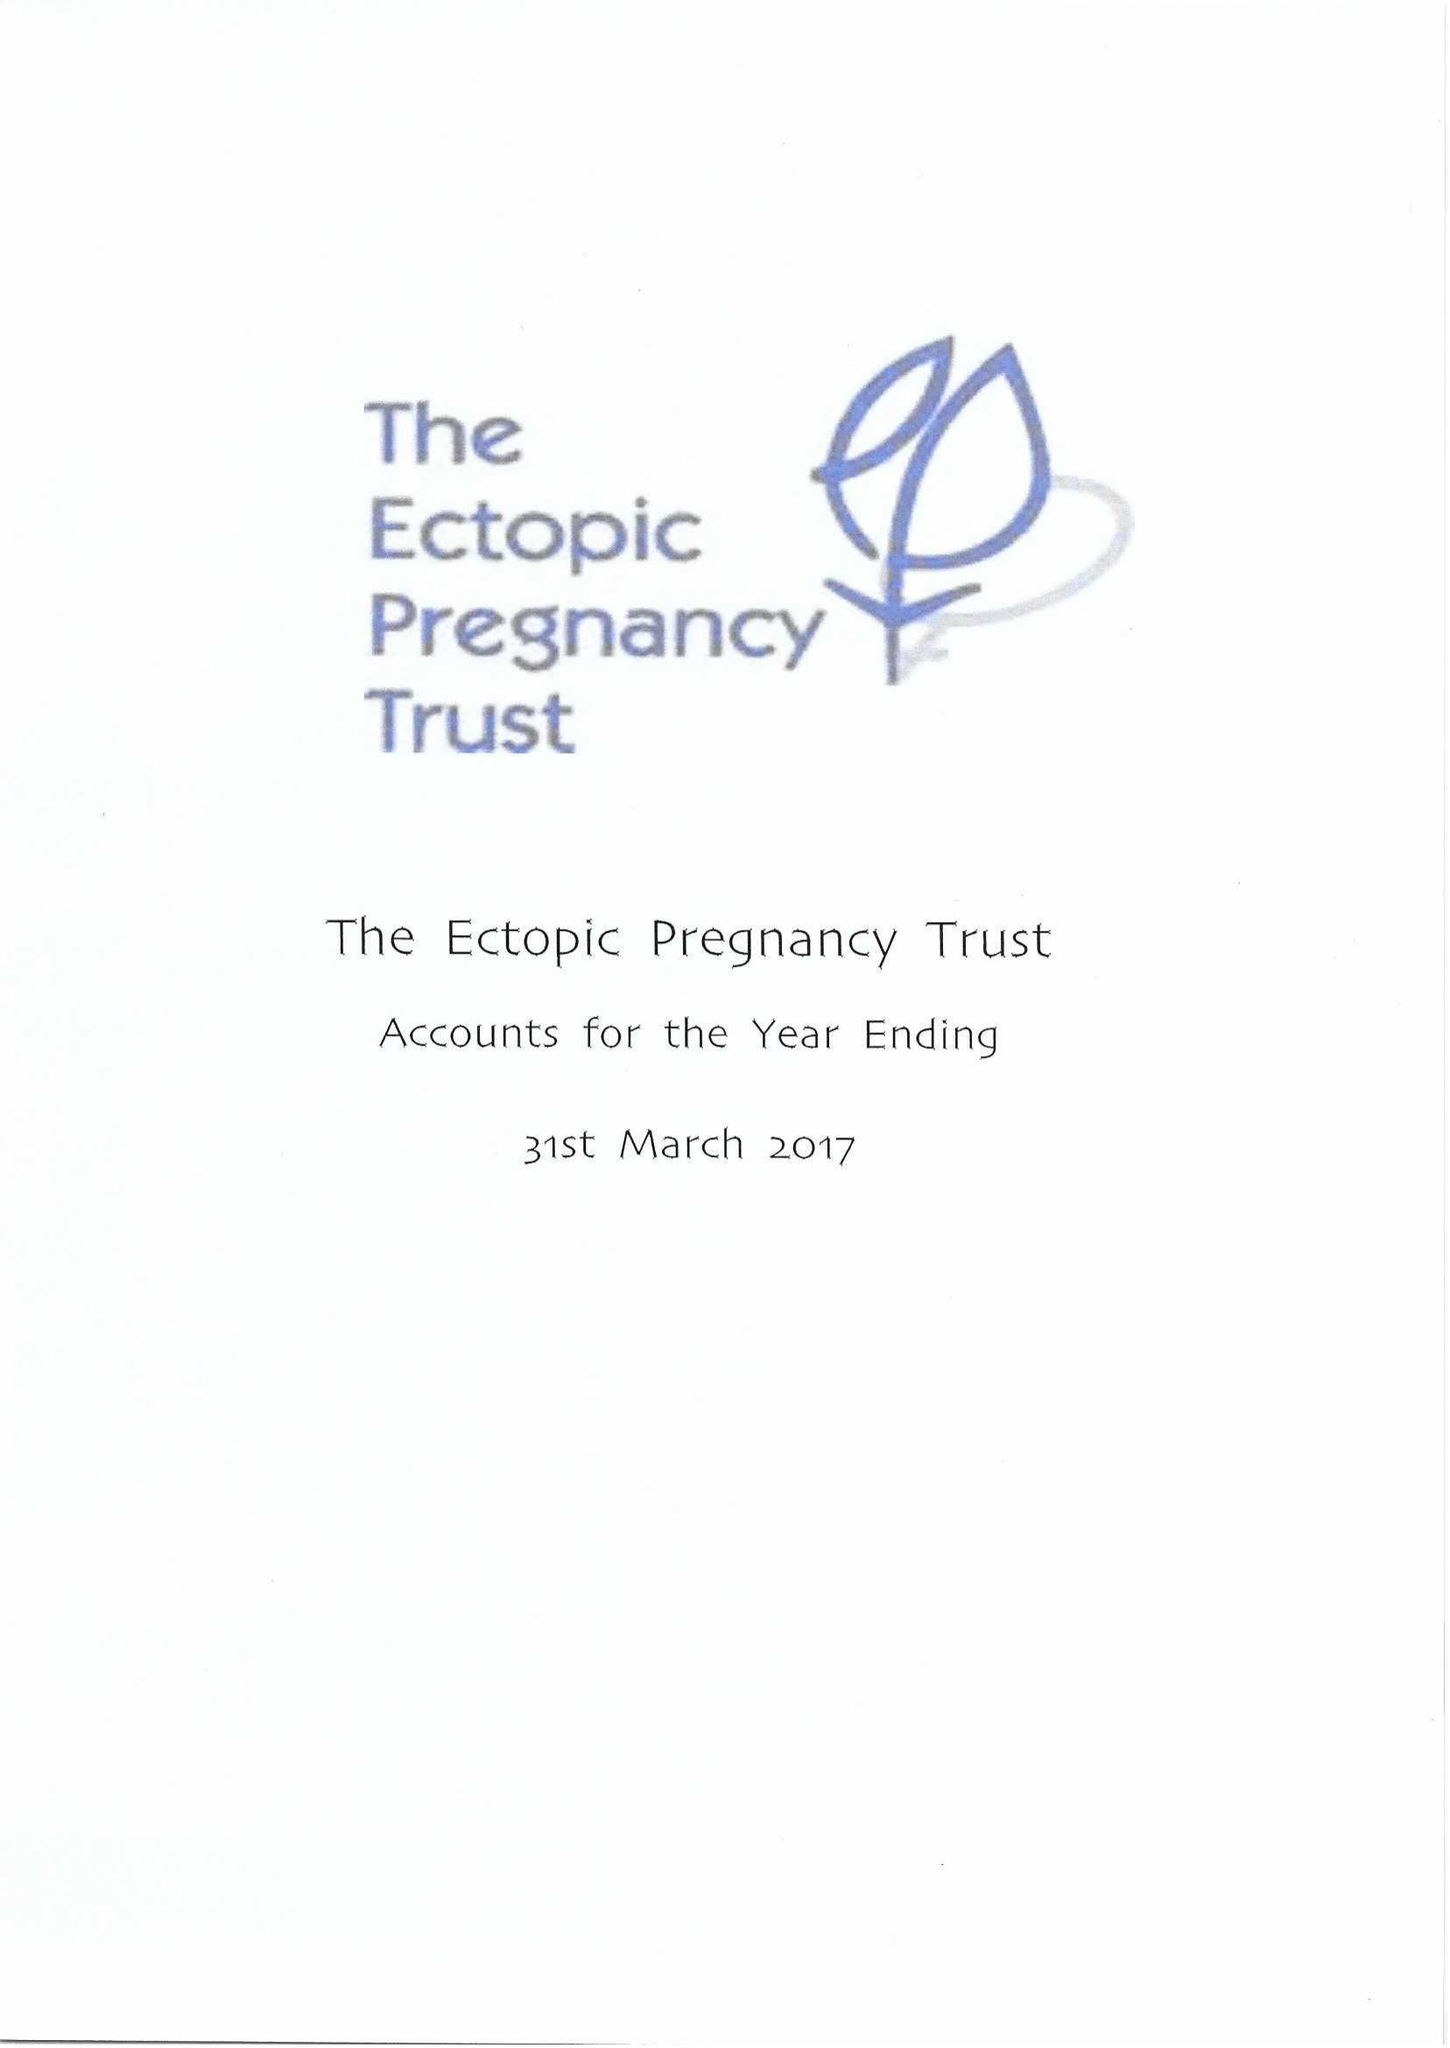What is the value for the charity_name?
Answer the question using a single word or phrase. The Ectopic Pregnancy Trust 